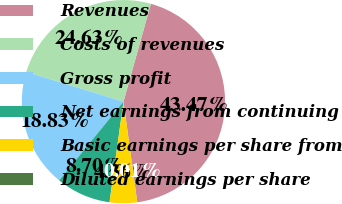<chart> <loc_0><loc_0><loc_500><loc_500><pie_chart><fcel>Revenues<fcel>Costs of revenues<fcel>Gross profit<fcel>Net earnings from continuing<fcel>Basic earnings per share from<fcel>Diluted earnings per share<nl><fcel>43.47%<fcel>24.63%<fcel>18.83%<fcel>8.7%<fcel>4.36%<fcel>0.01%<nl></chart> 